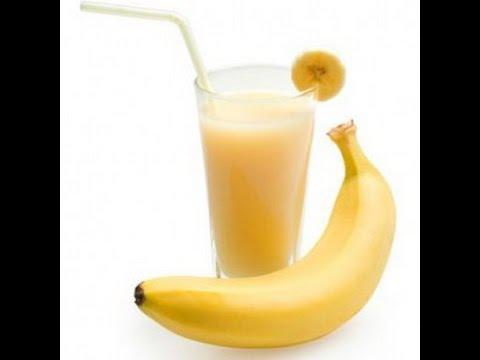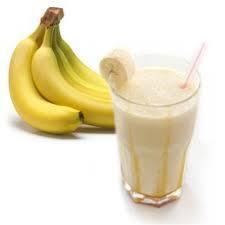The first image is the image on the left, the second image is the image on the right. For the images displayed, is the sentence "The left image contains one smoothie with a small banana slice in the rim of its glass." factually correct? Answer yes or no. Yes. The first image is the image on the left, the second image is the image on the right. Analyze the images presented: Is the assertion "An image includes a smoothie in a glass with a straw and garnish, in front of a bunch of bananas." valid? Answer yes or no. Yes. 